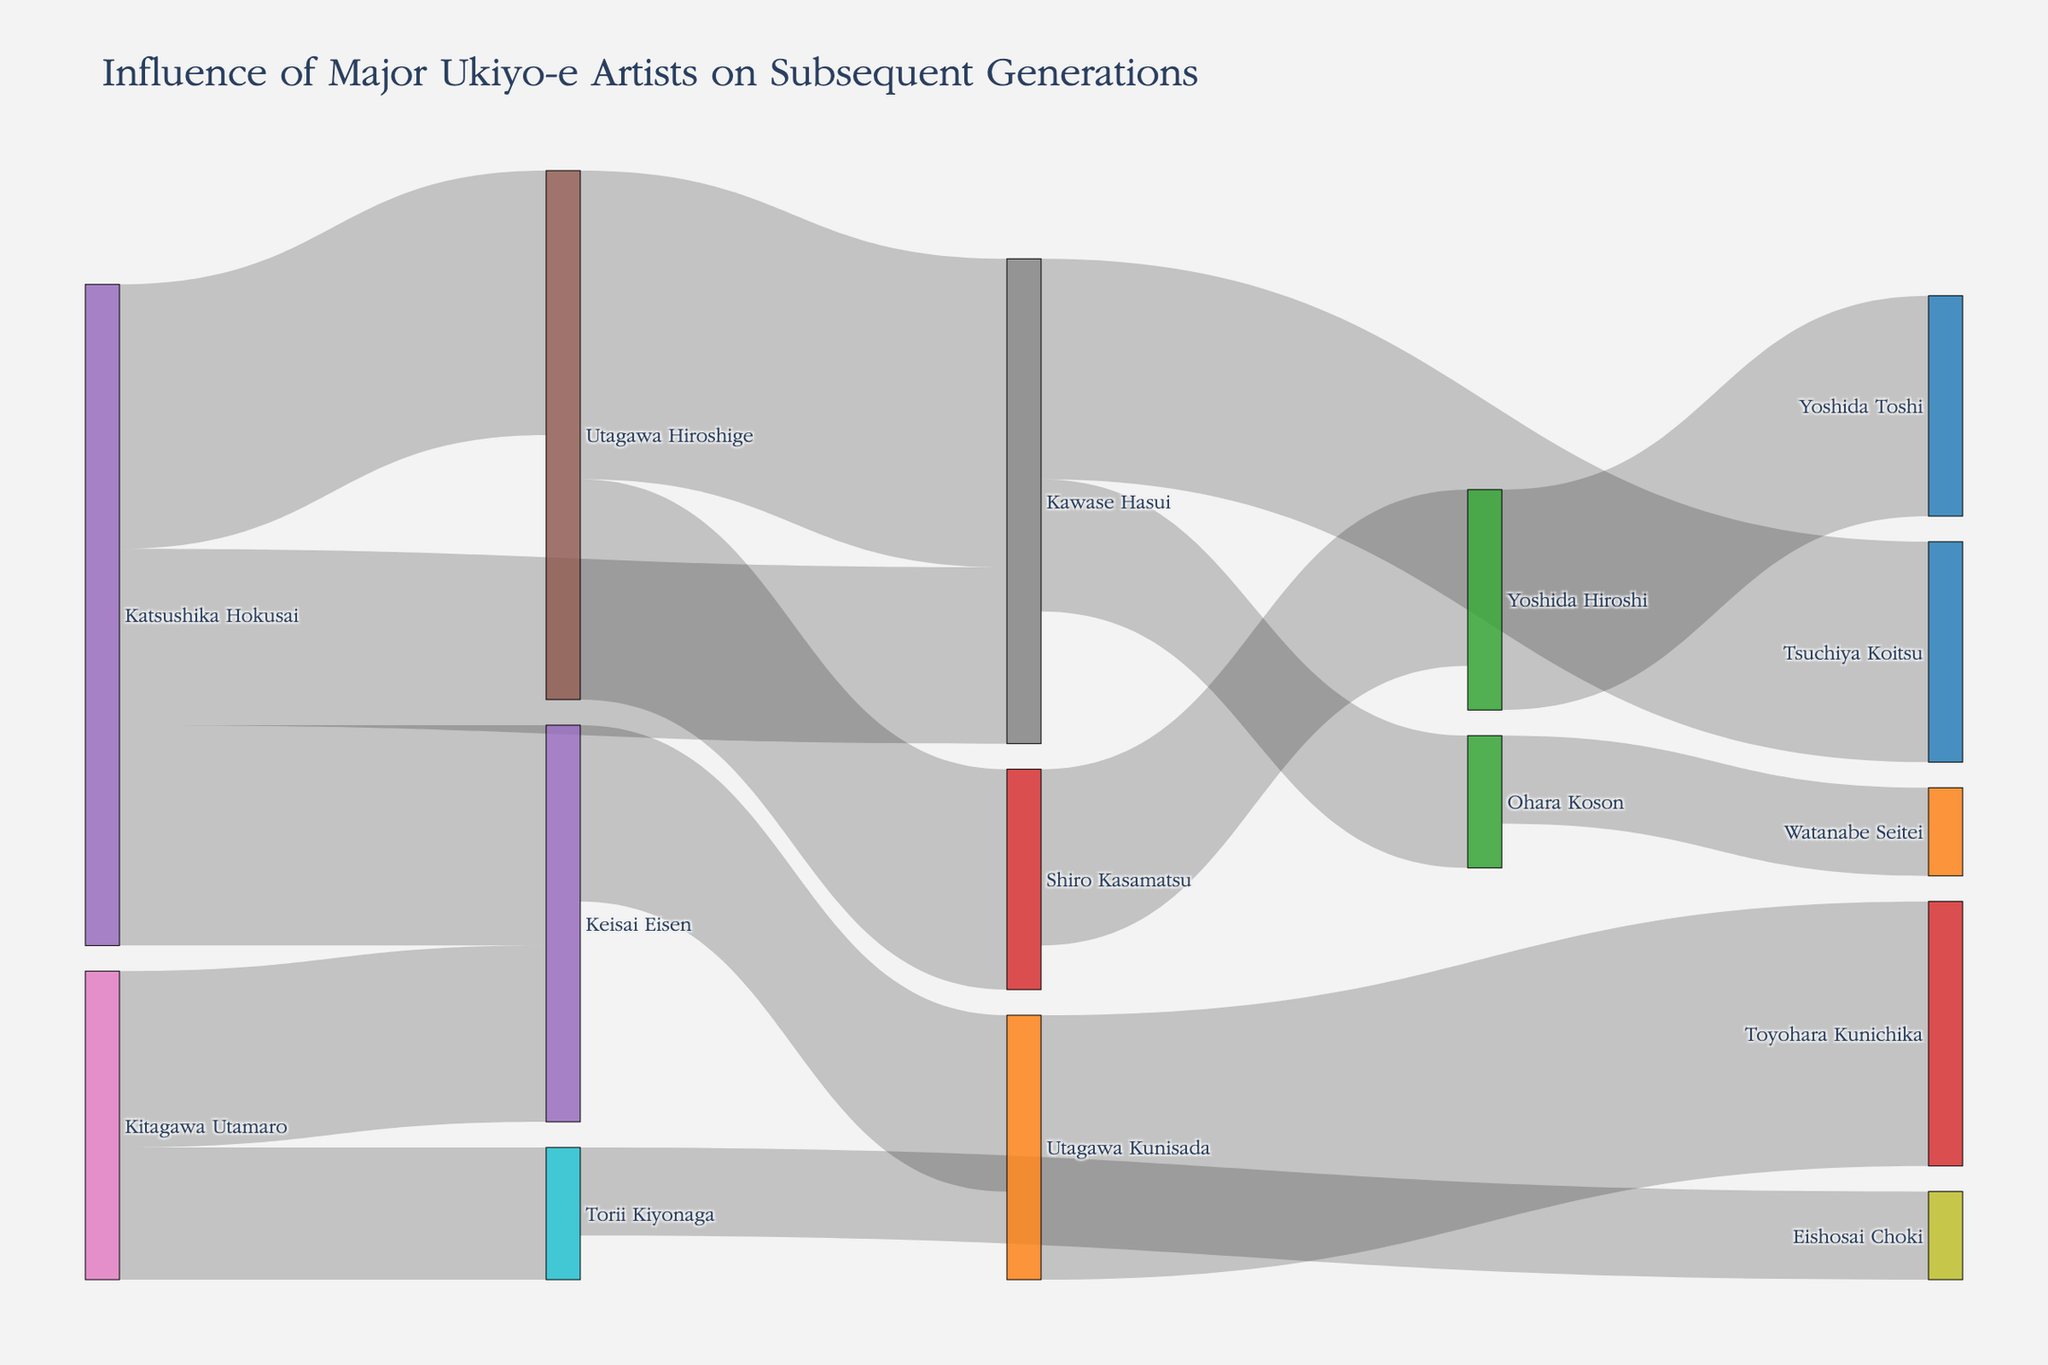How many artists did Katsushika Hokusai influence? To find out how many artists Katsushika Hokusai influenced, we count the number of targets linked to him. From the figure, Katsushika Hokusai influences Utagawa Hiroshige, Keisai Eisen, and Kawase Hasui. Therefore, the number of artists is 3.
Answer: 3 Which artist had the greatest influence on Kawase Hasui? To determine this, we look at the links connected to Kawase Hasui and compare their values. Katsushika Hokusai has a value of 20, while Utagawa Hiroshige has a value of 35. Since 35 is greater than 20, Utagawa Hiroshige had the greatest influence on Kawase Hasui.
Answer: Utagawa Hiroshige What is the cumulative value of influence that Utagawa Hiroshige had on other artists? We add up the values of all the links for which Utagawa Hiroshige is the source. These values are 35 (Kawase Hasui) and 25 (Shiro Kasamatsu). The sum is 35 + 25 = 60.
Answer: 60 Which two artists were influenced by both Katsushika Hokusai and Kitagawa Utamaro? To answer this, we look at the targets of both Katsushika Hokusai and Kitagawa Utamaro. Katsushika Hokusai influenced Utagawa Hiroshige, Keisai Eisen, and Kawase Hasui. Kitagawa Utamaro influenced Torii Kiyonaga and Keisai Eisen. The common artist in both lists is Keisai Eisen.
Answer: Keisai Eisen What is the total number of artists included in the diagram? To find the total number of unique artists, we count all nodes in the figure. The unique artists are Katsushika Hokusai, Utagawa Hiroshige, Keisai Eisen, Kawase Hasui, Shiro Kasamatsu, Kitagawa Utamaro, Torii Kiyonaga, Eishosai Choki, Utagawa Kunisada, Toyohara Kunichika, Tsuchiya Koitsu, Ohara Koson, Yoshida Hiroshi, Watanabe Seitei, and Yoshida Toshi. There are 15 artists in total.
Answer: 15 Between Kawase Hasui and Shiro Kasamatsu, who influenced more artists? To determine this, we count the number of target links for each artist. Kawase Hasui influenced Tsuchiya Koitsu and Ohara Koson, totaling 2 links. Shiro Kasamatsu influenced Yoshida Hiroshi, totaling 1 link. Thus, Kawase Hasui influenced more artists.
Answer: Kawase Hasui What's the total influence value attributed to the artists influenced by Kawase Hasui? To find this, we add up the influence values where Kawase Hasui is the source. The values are 25 (Tsuchiya Koitsu) and 15 (Ohara Koson). The sum is 25 + 15 = 40.
Answer: 40 Who has a higher influence value: Keisai Eisen or Utagawa Kunisada? To answer this, we compare their total influence values. Keisai Eisen has influences of 20 (Utagawa Kunisada), totaling 20. Utagawa Kunisada has influence of 30 (Toyohara Kunichika), totaling 30. Since 30 is greater than 20, Utagawa Kunisada has a higher influence value.
Answer: Utagawa Kunisada 